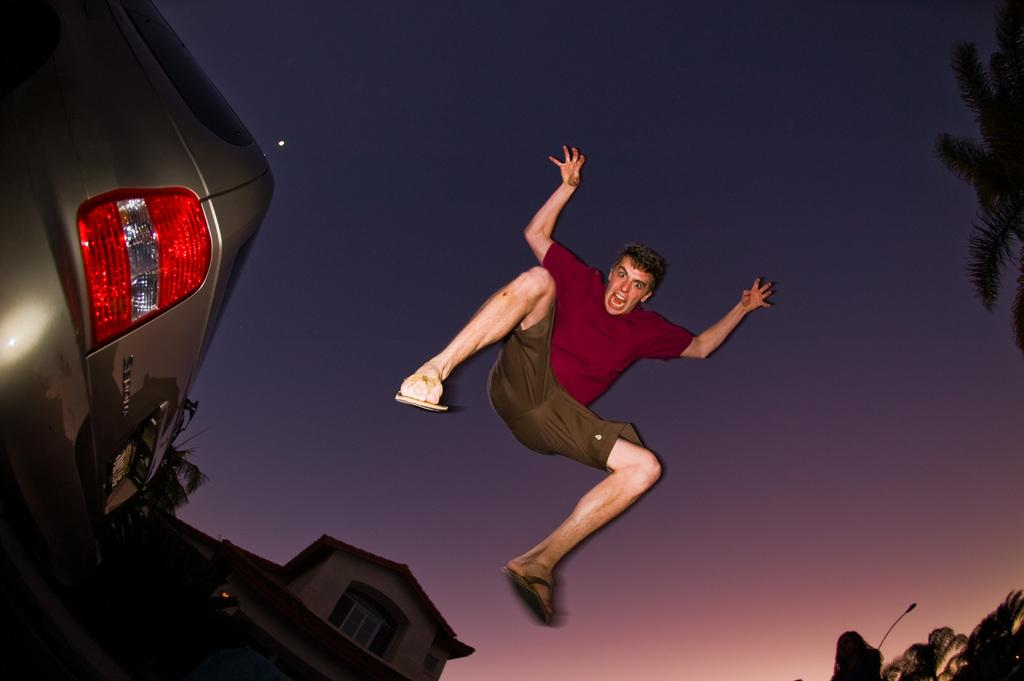What is the man doing in the image? The man is in the air in the image. What type of structure can be seen in the image? There is a house with windows in the image. What type of vegetation is present in the image? There are trees in the image. What mode of transportation is visible in the image? There is a vehicle in the image. What can be seen in the background of the image? The sky is visible in the background of the image. What type of lunch is the man eating while in the air in the image? There is no indication of the man eating lunch in the image; he is simply in the air. What is causing the man to laugh in the image? There is no indication of the man laughing in the image; he is just in the air. 